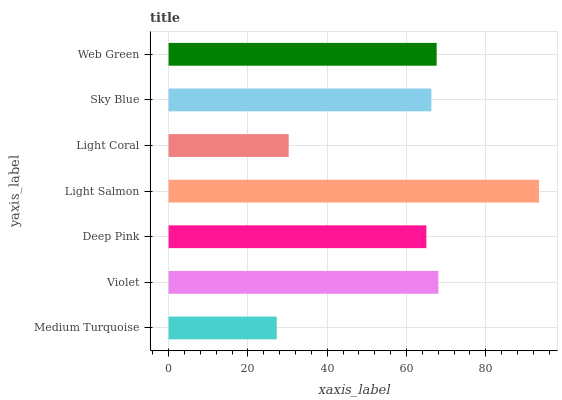Is Medium Turquoise the minimum?
Answer yes or no. Yes. Is Light Salmon the maximum?
Answer yes or no. Yes. Is Violet the minimum?
Answer yes or no. No. Is Violet the maximum?
Answer yes or no. No. Is Violet greater than Medium Turquoise?
Answer yes or no. Yes. Is Medium Turquoise less than Violet?
Answer yes or no. Yes. Is Medium Turquoise greater than Violet?
Answer yes or no. No. Is Violet less than Medium Turquoise?
Answer yes or no. No. Is Sky Blue the high median?
Answer yes or no. Yes. Is Sky Blue the low median?
Answer yes or no. Yes. Is Violet the high median?
Answer yes or no. No. Is Violet the low median?
Answer yes or no. No. 